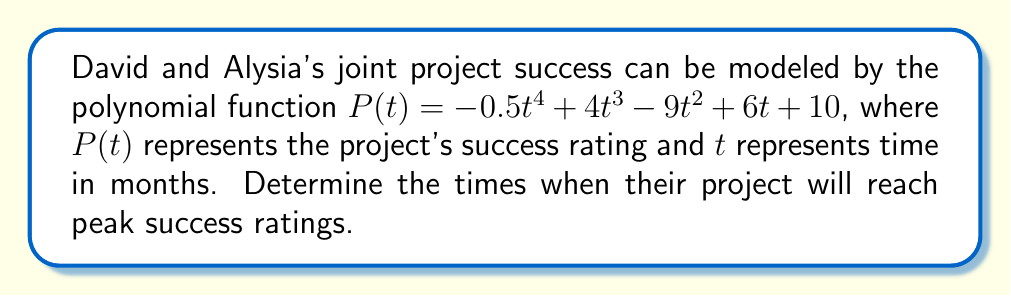Provide a solution to this math problem. To find the peak moments of David and Alysia's joint project, we need to analyze the roots of the derivative of the given polynomial function. Here's how we can do this:

1) First, let's find the derivative of $P(t)$:
   $$P'(t) = -2t^3 + 12t^2 - 18t + 6$$

2) The peak moments occur when $P'(t) = 0$. So, we need to solve:
   $$-2t^3 + 12t^2 - 18t + 6 = 0$$

3) This is a cubic equation. We can factor it:
   $$-2(t^3 - 6t^2 + 9t - 3) = 0$$
   $$-2(t - 1)(t^2 - 5t + 3) = 0$$

4) Using the quadratic formula on $t^2 - 5t + 3 = 0$:
   $$t = \frac{5 \pm \sqrt{25 - 12}}{2} = \frac{5 \pm \sqrt{13}}{2}$$

5) Therefore, the roots of $P'(t)$ are:
   $$t = 1, \frac{5 + \sqrt{13}}{2}, \frac{5 - \sqrt{13}}{2}$$

6) To determine which of these are maxima (peaks), we need to check the second derivative:
   $$P''(t) = -6t^2 + 24t - 18$$

7) Evaluating $P''(t)$ at each critical point:
   At $t = 1$: $P''(1) = -6 + 24 - 18 = 0$ (inflection point)
   At $t = \frac{5 + \sqrt{13}}{2}$: $P''(\frac{5 + \sqrt{13}}{2}) < 0$ (local maximum)
   At $t = \frac{5 - \sqrt{13}}{2}$: $P''(\frac{5 - \sqrt{13}}{2}) > 0$ (local minimum)

Therefore, the project will reach a peak success rating at $t = \frac{5 + \sqrt{13}}{2}$ months.
Answer: The project will reach its peak success rating at $\frac{5 + \sqrt{13}}{2} \approx 4.30$ months. 